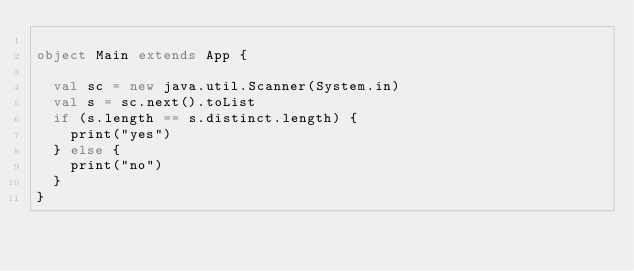Convert code to text. <code><loc_0><loc_0><loc_500><loc_500><_Scala_>
object Main extends App {
  
  val sc = new java.util.Scanner(System.in) 
  val s = sc.next().toList
  if (s.length == s.distinct.length) {
    print("yes")
  } else {
    print("no")
  }
}
</code> 